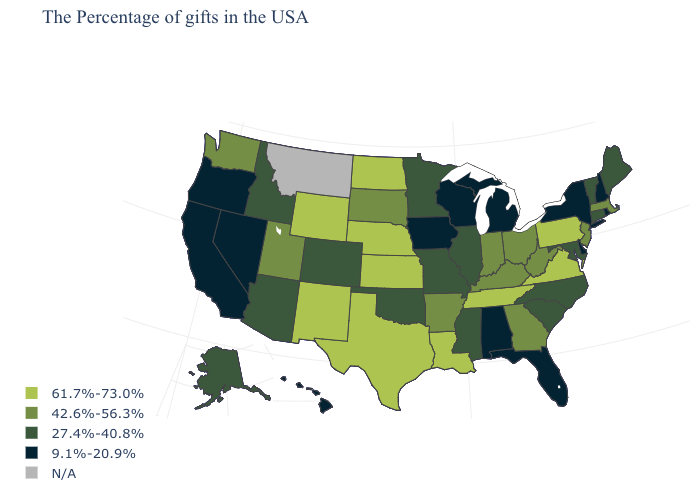What is the value of Massachusetts?
Short answer required. 42.6%-56.3%. What is the value of Illinois?
Short answer required. 27.4%-40.8%. What is the value of Iowa?
Answer briefly. 9.1%-20.9%. How many symbols are there in the legend?
Write a very short answer. 5. Among the states that border California , which have the lowest value?
Write a very short answer. Nevada, Oregon. Name the states that have a value in the range 42.6%-56.3%?
Concise answer only. Massachusetts, New Jersey, West Virginia, Ohio, Georgia, Kentucky, Indiana, Arkansas, South Dakota, Utah, Washington. Does the first symbol in the legend represent the smallest category?
Answer briefly. No. What is the highest value in states that border Washington?
Concise answer only. 27.4%-40.8%. Which states have the highest value in the USA?
Keep it brief. Pennsylvania, Virginia, Tennessee, Louisiana, Kansas, Nebraska, Texas, North Dakota, Wyoming, New Mexico. What is the value of Florida?
Concise answer only. 9.1%-20.9%. Which states hav the highest value in the Northeast?
Quick response, please. Pennsylvania. What is the value of Texas?
Quick response, please. 61.7%-73.0%. Name the states that have a value in the range N/A?
Give a very brief answer. Montana. What is the highest value in the USA?
Short answer required. 61.7%-73.0%. Name the states that have a value in the range 42.6%-56.3%?
Keep it brief. Massachusetts, New Jersey, West Virginia, Ohio, Georgia, Kentucky, Indiana, Arkansas, South Dakota, Utah, Washington. 